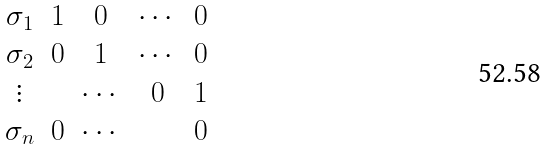<formula> <loc_0><loc_0><loc_500><loc_500>\begin{matrix} \sigma _ { 1 } & 1 & 0 & \cdots & 0 \\ \sigma _ { 2 } & 0 & 1 & \cdots & 0 \\ \vdots & & \cdots & 0 & 1 \\ \sigma _ { n } & 0 & \cdots & & 0 \end{matrix}</formula> 